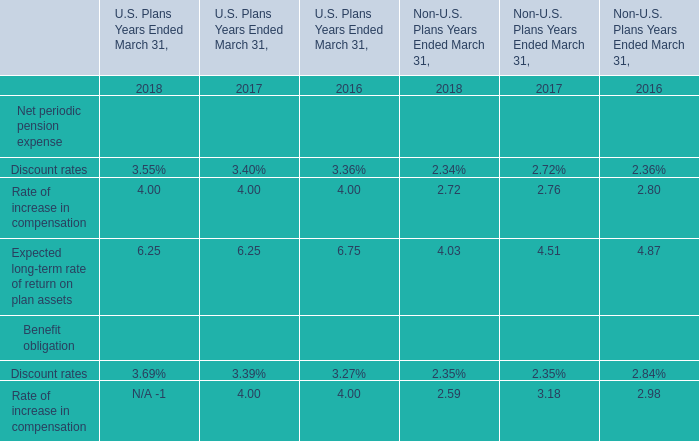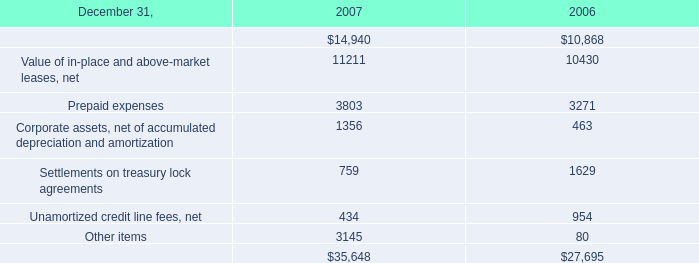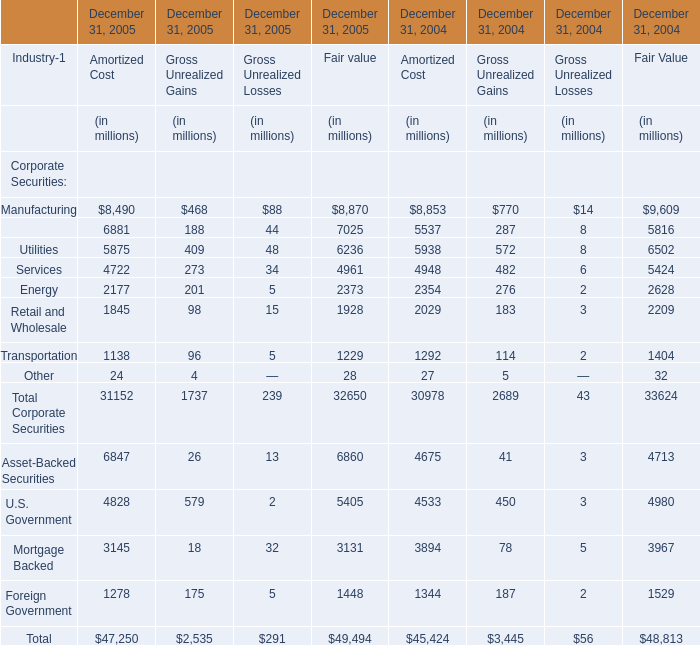What's the total value of all elements for Amortized Cost that are smaller than 2000 in 2005? (in million) 
Computations: (((1845 + 1138) + 24) + 1278)
Answer: 4285.0. 